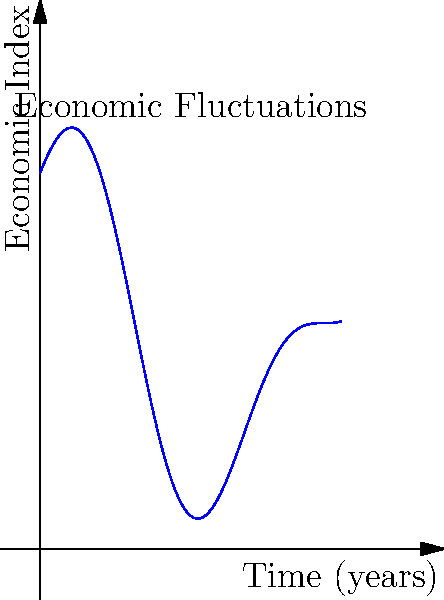Given the graph representing global economic fluctuations over a 20-year period, modeled by the function $f(t) = 5\sin(\frac{t}{2}) + 10\cos(\frac{t}{4}) + 15$, where $t$ is time in years and $f(t)$ is the economic index, determine the amplitude of the fastest oscillating component. How might this rapid fluctuation impact current geopolitical tensions? To determine the amplitude of the fastest oscillating component:

1) The function consists of two periodic components:
   $5\sin(\frac{t}{2})$ and $10\cos(\frac{t}{4})$

2) The frequency of oscillation is determined by the coefficient inside the trigonometric function:
   $\frac{1}{2}$ for sine and $\frac{1}{4}$ for cosine

3) The larger coefficient ($\frac{1}{2}$) corresponds to the faster oscillation

4) The amplitude of this component is the coefficient outside the sine function: 5

5) Therefore, the amplitude of the fastest oscillating component is 5

Impact on current geopolitical tensions:
This rapid fluctuation with an amplitude of 5 in the economic index over relatively short periods could lead to:

- Increased economic uncertainty
- Potential for short-term gains or losses in international trade
- Stress on diplomatic relations due to rapidly changing economic conditions
- Pressure on governments to respond quickly to economic shifts
- Possible exacerbation of existing tensions between nations competing for economic advantage

These factors could significantly influence current geopolitical dynamics, potentially escalating tensions or creating opportunities for cooperation in managing global economic volatility.
Answer: 5; Rapid economic fluctuations may intensify current geopolitical tensions through increased uncertainty and competition. 